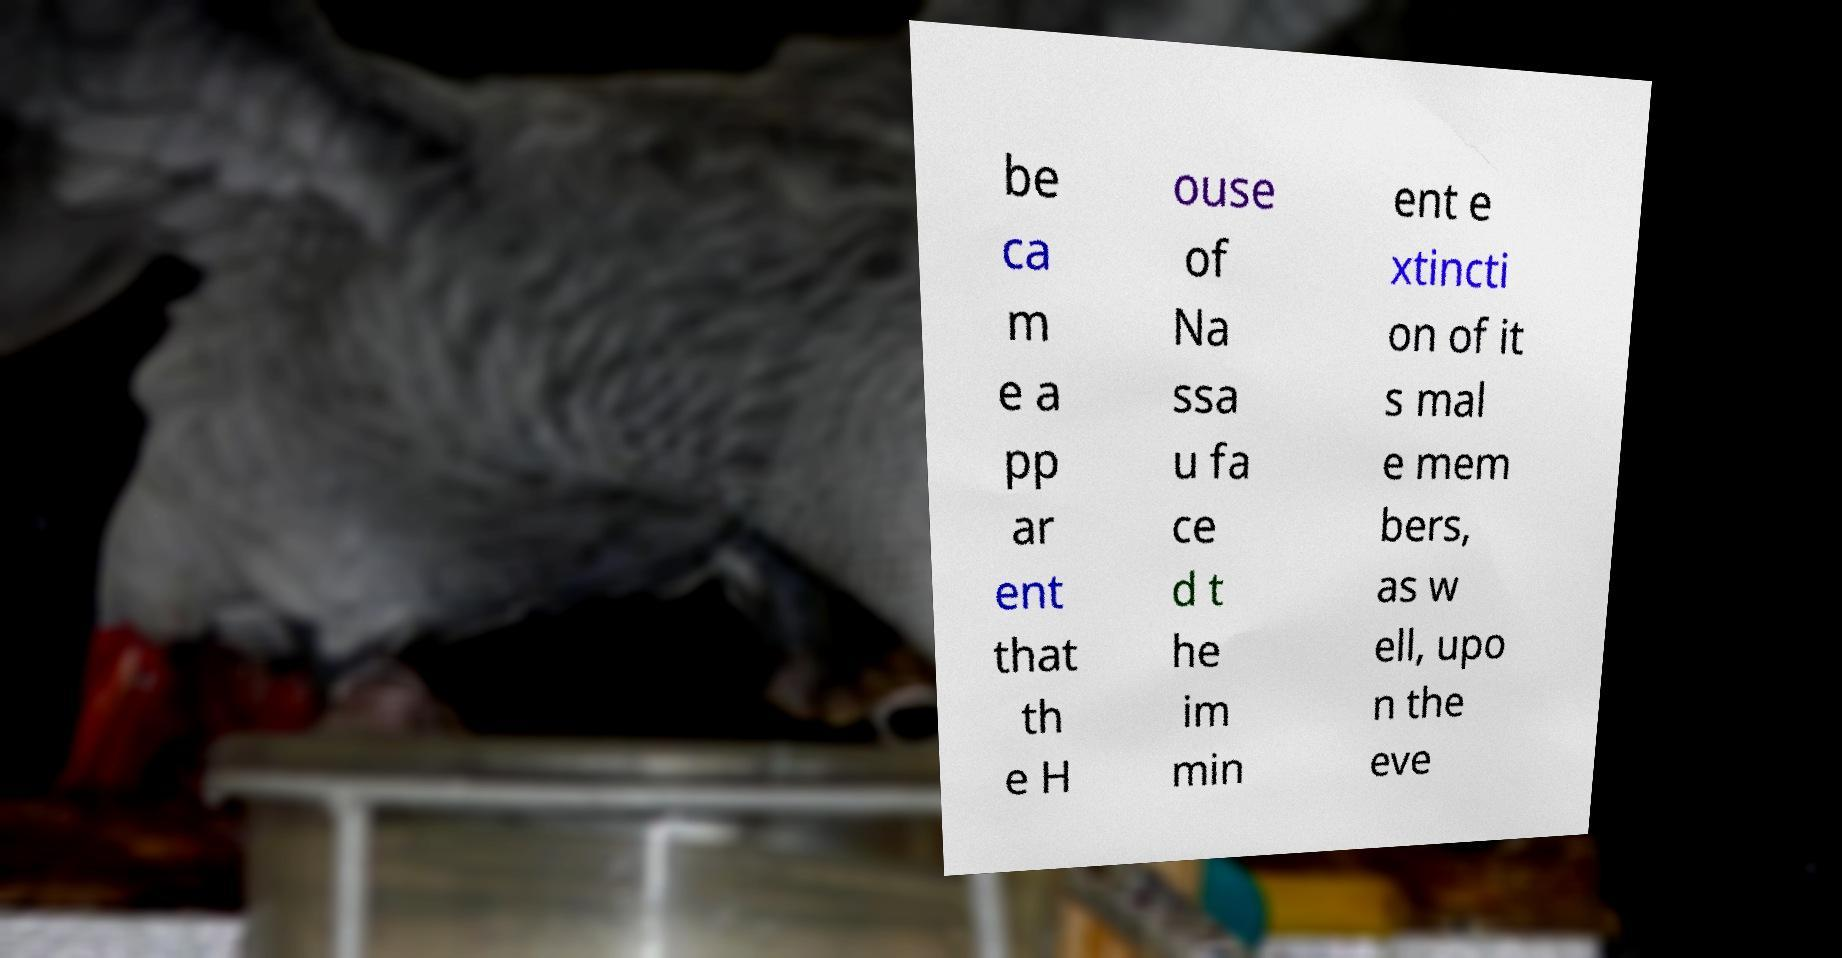For documentation purposes, I need the text within this image transcribed. Could you provide that? be ca m e a pp ar ent that th e H ouse of Na ssa u fa ce d t he im min ent e xtincti on of it s mal e mem bers, as w ell, upo n the eve 